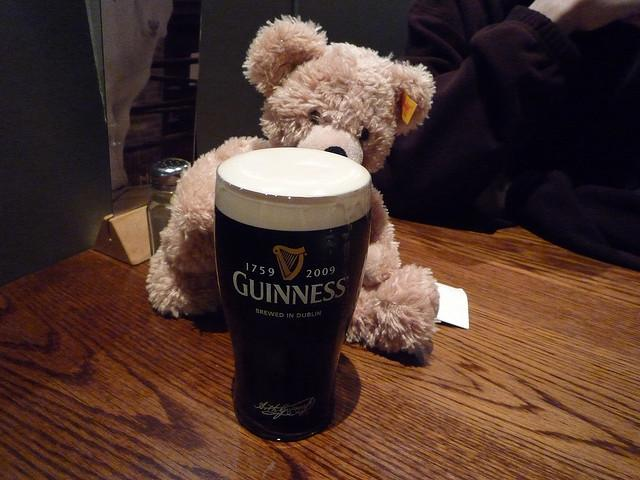What plant adds bitterness to this beverage? hops 